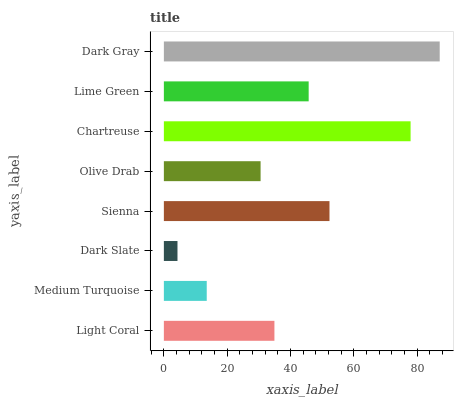Is Dark Slate the minimum?
Answer yes or no. Yes. Is Dark Gray the maximum?
Answer yes or no. Yes. Is Medium Turquoise the minimum?
Answer yes or no. No. Is Medium Turquoise the maximum?
Answer yes or no. No. Is Light Coral greater than Medium Turquoise?
Answer yes or no. Yes. Is Medium Turquoise less than Light Coral?
Answer yes or no. Yes. Is Medium Turquoise greater than Light Coral?
Answer yes or no. No. Is Light Coral less than Medium Turquoise?
Answer yes or no. No. Is Lime Green the high median?
Answer yes or no. Yes. Is Light Coral the low median?
Answer yes or no. Yes. Is Light Coral the high median?
Answer yes or no. No. Is Sienna the low median?
Answer yes or no. No. 